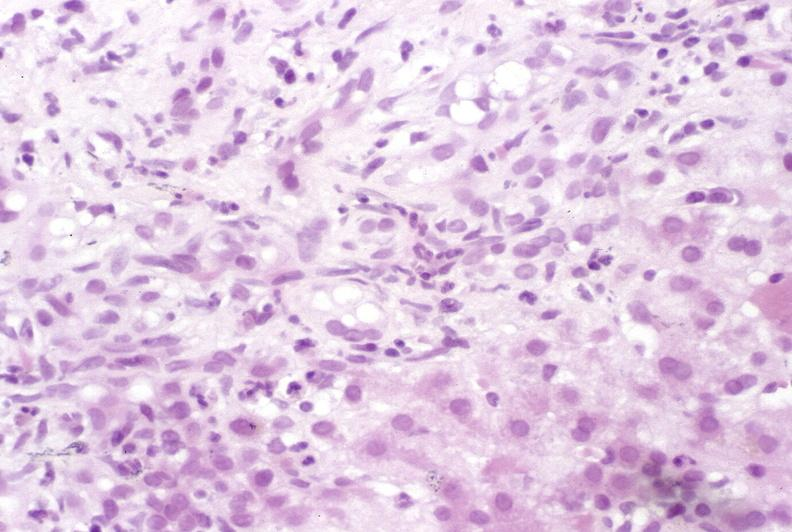what is present?
Answer the question using a single word or phrase. Liver 